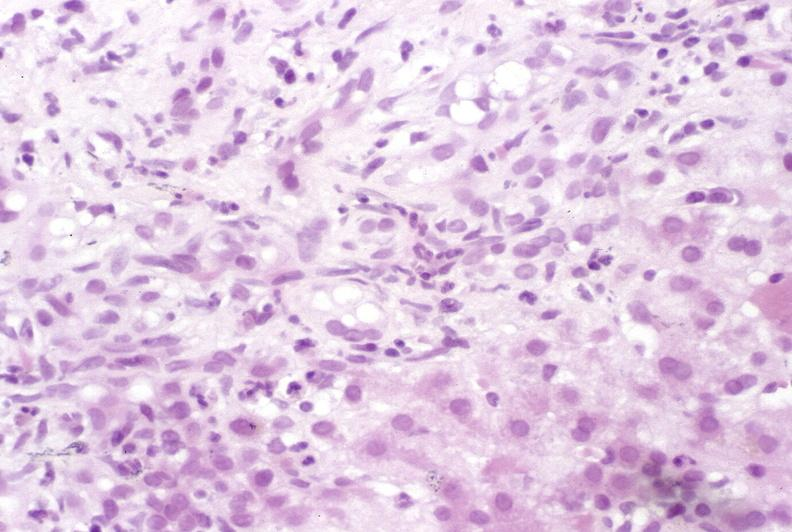what is present?
Answer the question using a single word or phrase. Liver 